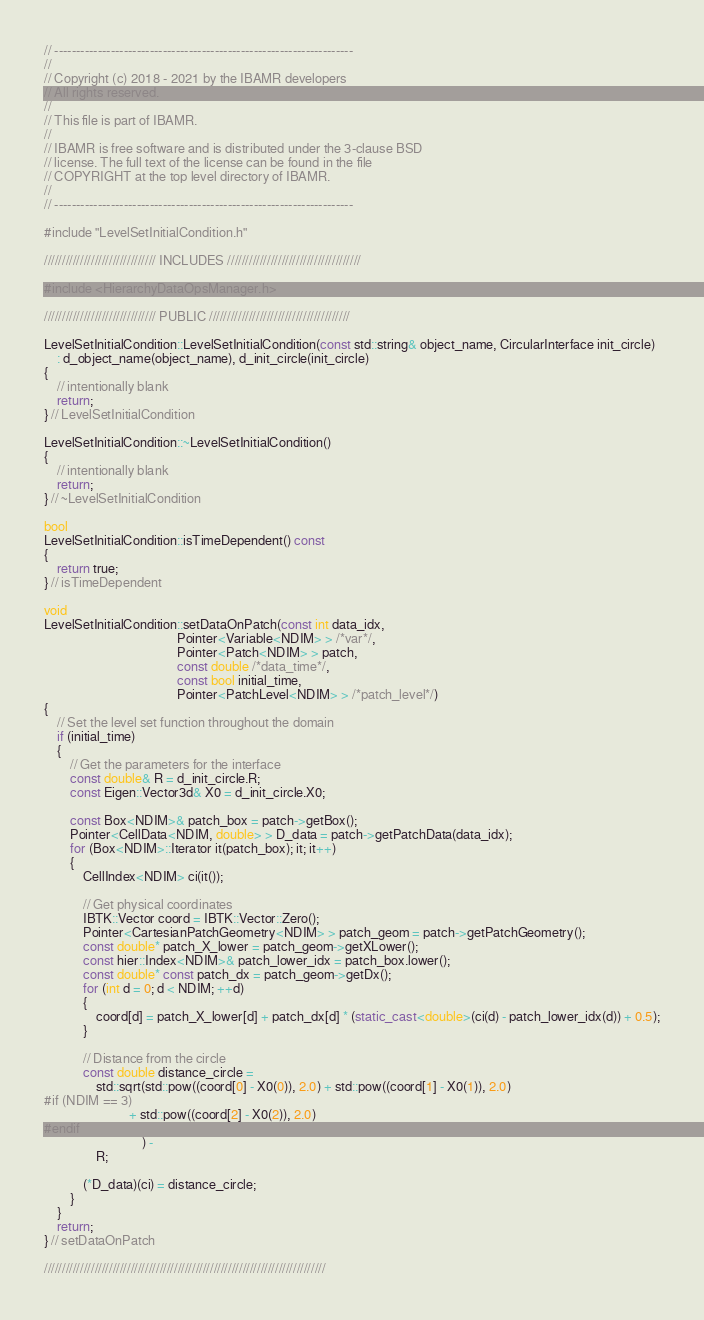Convert code to text. <code><loc_0><loc_0><loc_500><loc_500><_C++_>// ---------------------------------------------------------------------
//
// Copyright (c) 2018 - 2021 by the IBAMR developers
// All rights reserved.
//
// This file is part of IBAMR.
//
// IBAMR is free software and is distributed under the 3-clause BSD
// license. The full text of the license can be found in the file
// COPYRIGHT at the top level directory of IBAMR.
//
// ---------------------------------------------------------------------

#include "LevelSetInitialCondition.h"

/////////////////////////////// INCLUDES /////////////////////////////////////

#include <HierarchyDataOpsManager.h>

/////////////////////////////// PUBLIC ///////////////////////////////////////

LevelSetInitialCondition::LevelSetInitialCondition(const std::string& object_name, CircularInterface init_circle)
    : d_object_name(object_name), d_init_circle(init_circle)
{
    // intentionally blank
    return;
} // LevelSetInitialCondition

LevelSetInitialCondition::~LevelSetInitialCondition()
{
    // intentionally blank
    return;
} // ~LevelSetInitialCondition

bool
LevelSetInitialCondition::isTimeDependent() const
{
    return true;
} // isTimeDependent

void
LevelSetInitialCondition::setDataOnPatch(const int data_idx,
                                         Pointer<Variable<NDIM> > /*var*/,
                                         Pointer<Patch<NDIM> > patch,
                                         const double /*data_time*/,
                                         const bool initial_time,
                                         Pointer<PatchLevel<NDIM> > /*patch_level*/)
{
    // Set the level set function throughout the domain
    if (initial_time)
    {
        // Get the parameters for the interface
        const double& R = d_init_circle.R;
        const Eigen::Vector3d& X0 = d_init_circle.X0;

        const Box<NDIM>& patch_box = patch->getBox();
        Pointer<CellData<NDIM, double> > D_data = patch->getPatchData(data_idx);
        for (Box<NDIM>::Iterator it(patch_box); it; it++)
        {
            CellIndex<NDIM> ci(it());

            // Get physical coordinates
            IBTK::Vector coord = IBTK::Vector::Zero();
            Pointer<CartesianPatchGeometry<NDIM> > patch_geom = patch->getPatchGeometry();
            const double* patch_X_lower = patch_geom->getXLower();
            const hier::Index<NDIM>& patch_lower_idx = patch_box.lower();
            const double* const patch_dx = patch_geom->getDx();
            for (int d = 0; d < NDIM; ++d)
            {
                coord[d] = patch_X_lower[d] + patch_dx[d] * (static_cast<double>(ci(d) - patch_lower_idx(d)) + 0.5);
            }

            // Distance from the circle
            const double distance_circle =
                std::sqrt(std::pow((coord[0] - X0(0)), 2.0) + std::pow((coord[1] - X0(1)), 2.0)
#if (NDIM == 3)
                          + std::pow((coord[2] - X0(2)), 2.0)
#endif
                              ) -
                R;

            (*D_data)(ci) = distance_circle;
        }
    }
    return;
} // setDataOnPatch

//////////////////////////////////////////////////////////////////////////////
</code> 